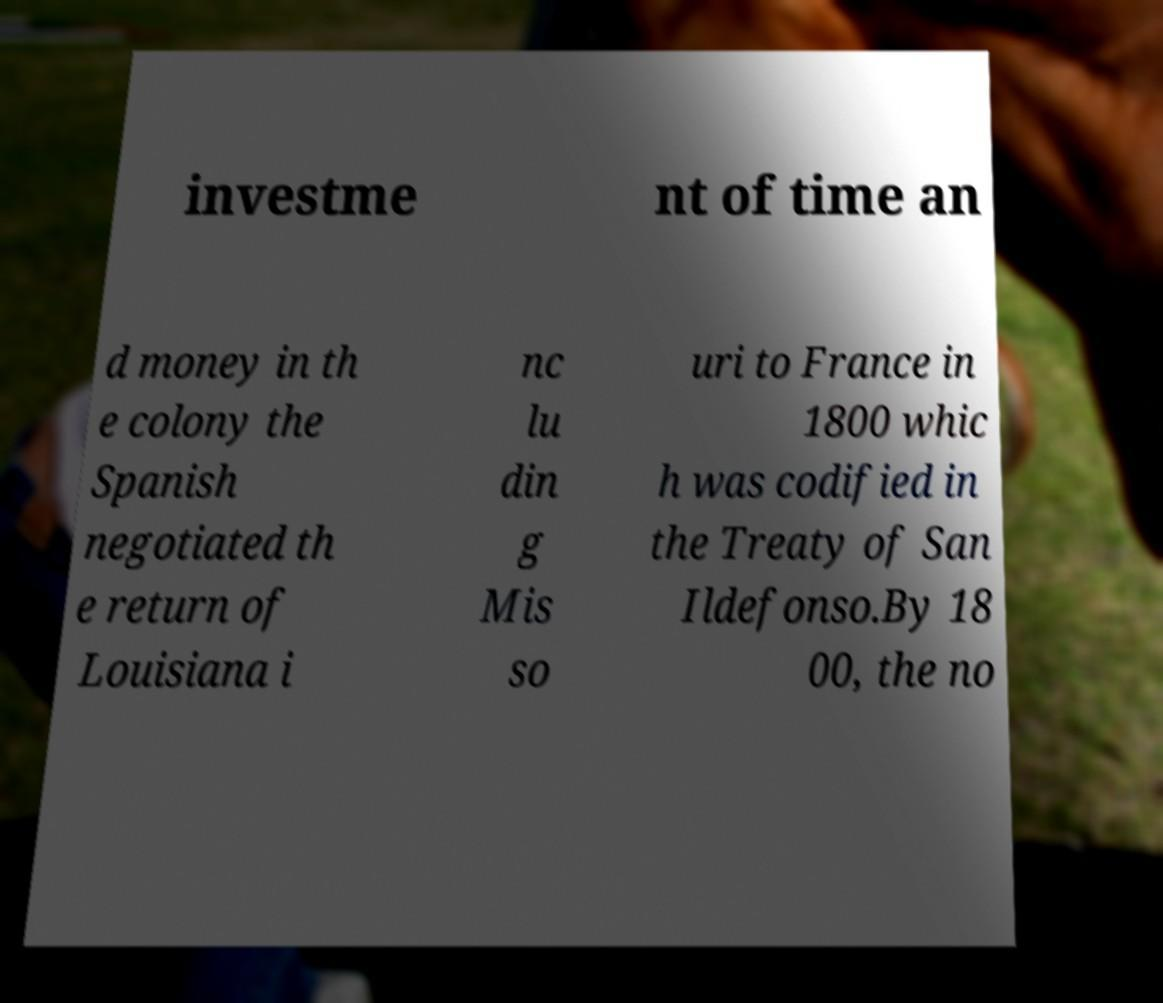Can you accurately transcribe the text from the provided image for me? investme nt of time an d money in th e colony the Spanish negotiated th e return of Louisiana i nc lu din g Mis so uri to France in 1800 whic h was codified in the Treaty of San Ildefonso.By 18 00, the no 